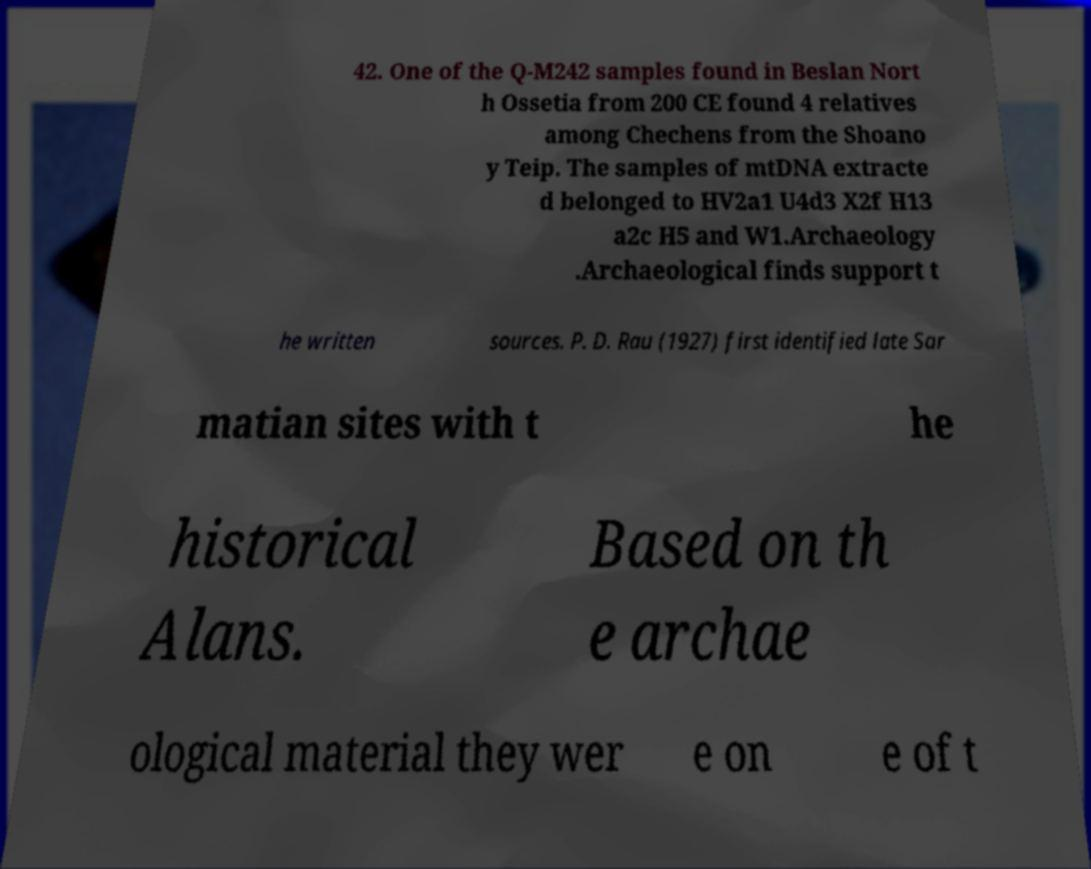Can you accurately transcribe the text from the provided image for me? 42. One of the Q-M242 samples found in Beslan Nort h Ossetia from 200 CE found 4 relatives among Chechens from the Shoano y Teip. The samples of mtDNA extracte d belonged to HV2a1 U4d3 X2f H13 a2c H5 and W1.Archaeology .Archaeological finds support t he written sources. P. D. Rau (1927) first identified late Sar matian sites with t he historical Alans. Based on th e archae ological material they wer e on e of t 